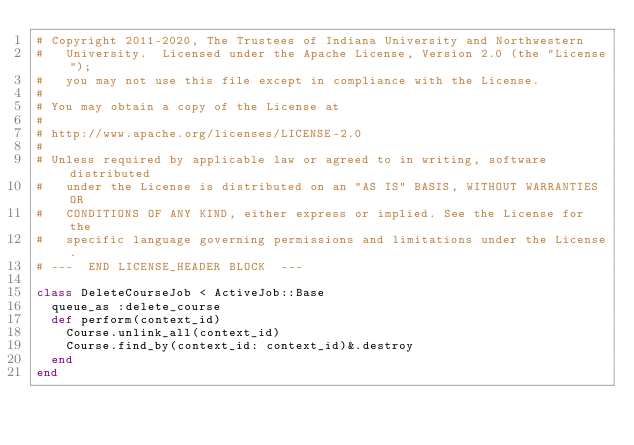Convert code to text. <code><loc_0><loc_0><loc_500><loc_500><_Ruby_># Copyright 2011-2020, The Trustees of Indiana University and Northwestern
#   University.  Licensed under the Apache License, Version 2.0 (the "License");
#   you may not use this file except in compliance with the License.
#
# You may obtain a copy of the License at
#
# http://www.apache.org/licenses/LICENSE-2.0
#
# Unless required by applicable law or agreed to in writing, software distributed
#   under the License is distributed on an "AS IS" BASIS, WITHOUT WARRANTIES OR
#   CONDITIONS OF ANY KIND, either express or implied. See the License for the
#   specific language governing permissions and limitations under the License.
# ---  END LICENSE_HEADER BLOCK  ---

class DeleteCourseJob < ActiveJob::Base
  queue_as :delete_course
  def perform(context_id)
    Course.unlink_all(context_id)
    Course.find_by(context_id: context_id)&.destroy
  end
end
</code> 